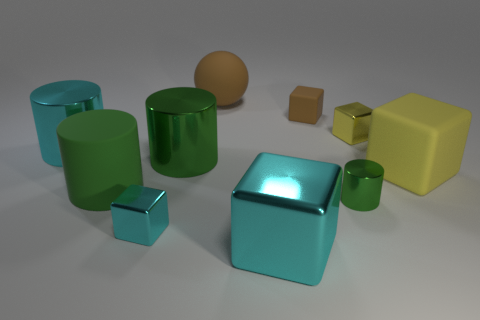Could you tell me which objects in the picture are the same color? In the image, there are groups of objects sharing the same color. The most prominent are the two teal blue objects—a large cube and a smaller, similar-shape object. Additionally, there are a few green objects with a similar tone that include two cylinders and a smaller cube. 